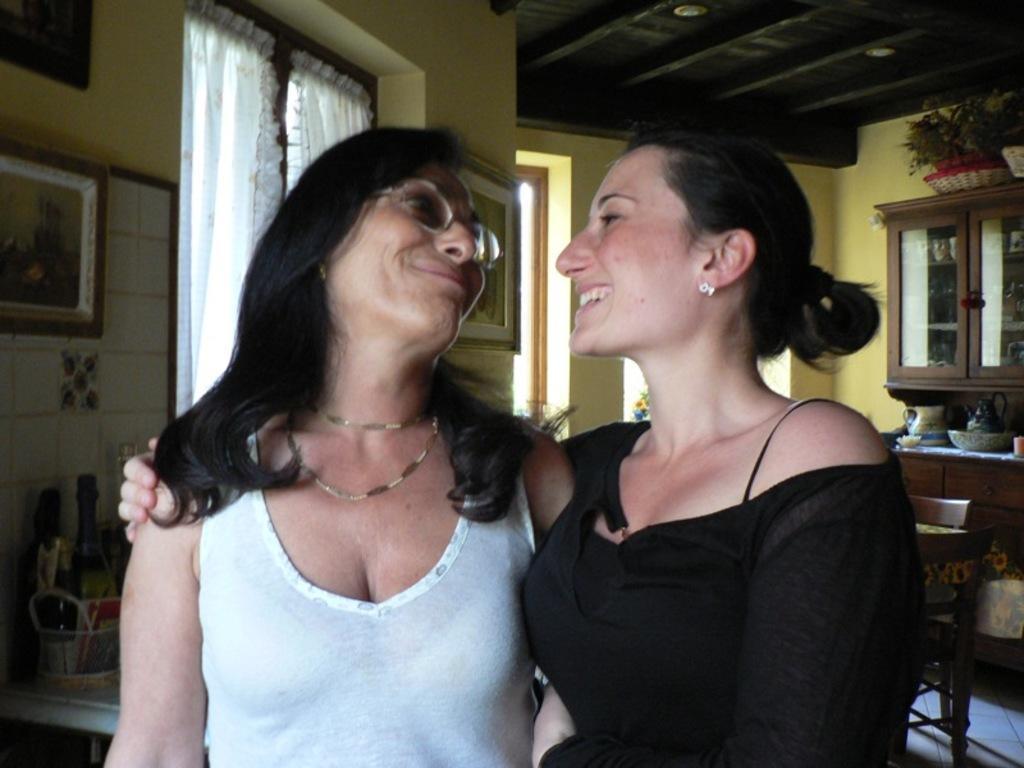Describe this image in one or two sentences. In this picture I can see there are two women standing and smiling and in the backdrop I can see there is a wall and a table. 